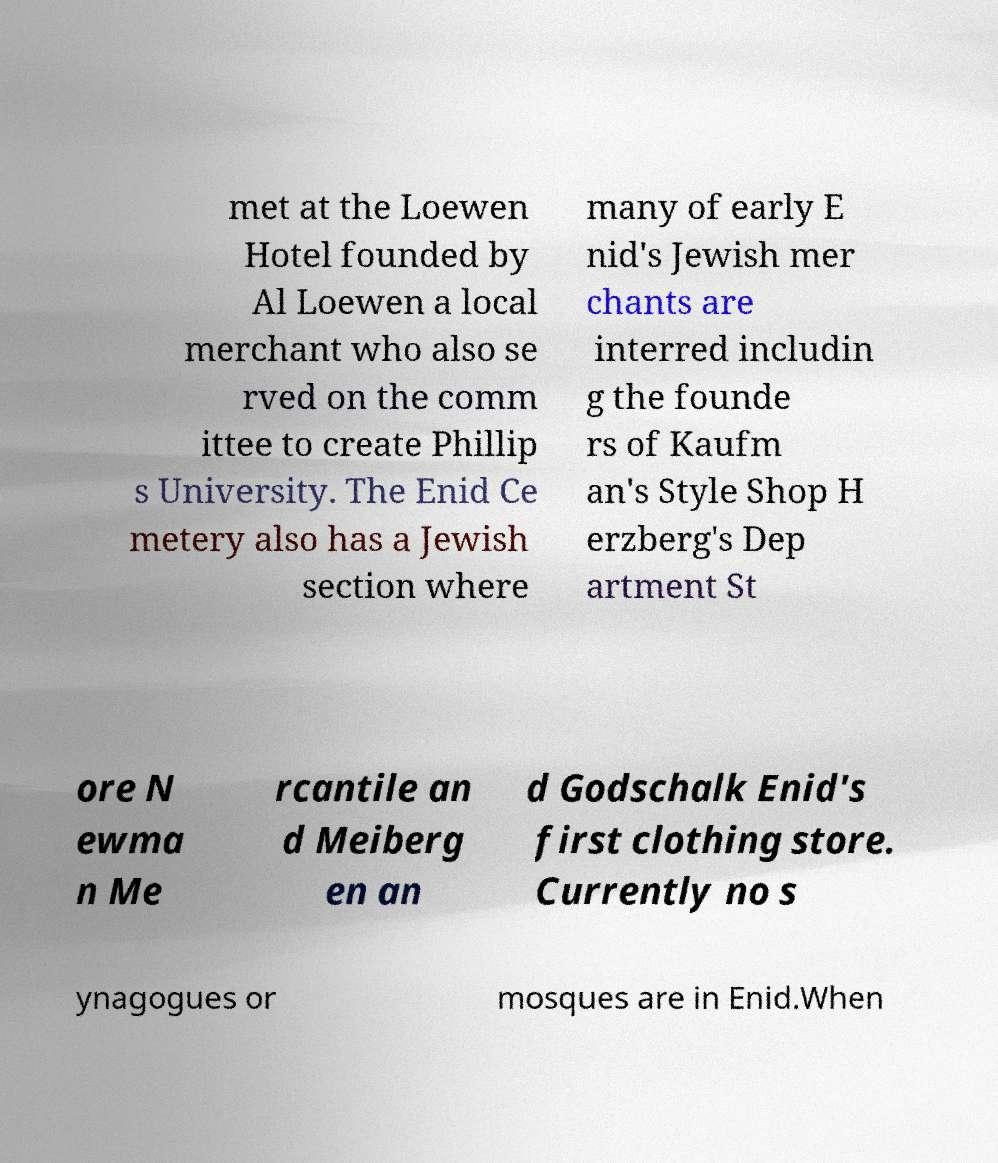Can you read and provide the text displayed in the image?This photo seems to have some interesting text. Can you extract and type it out for me? met at the Loewen Hotel founded by Al Loewen a local merchant who also se rved on the comm ittee to create Phillip s University. The Enid Ce metery also has a Jewish section where many of early E nid's Jewish mer chants are interred includin g the founde rs of Kaufm an's Style Shop H erzberg's Dep artment St ore N ewma n Me rcantile an d Meiberg en an d Godschalk Enid's first clothing store. Currently no s ynagogues or mosques are in Enid.When 